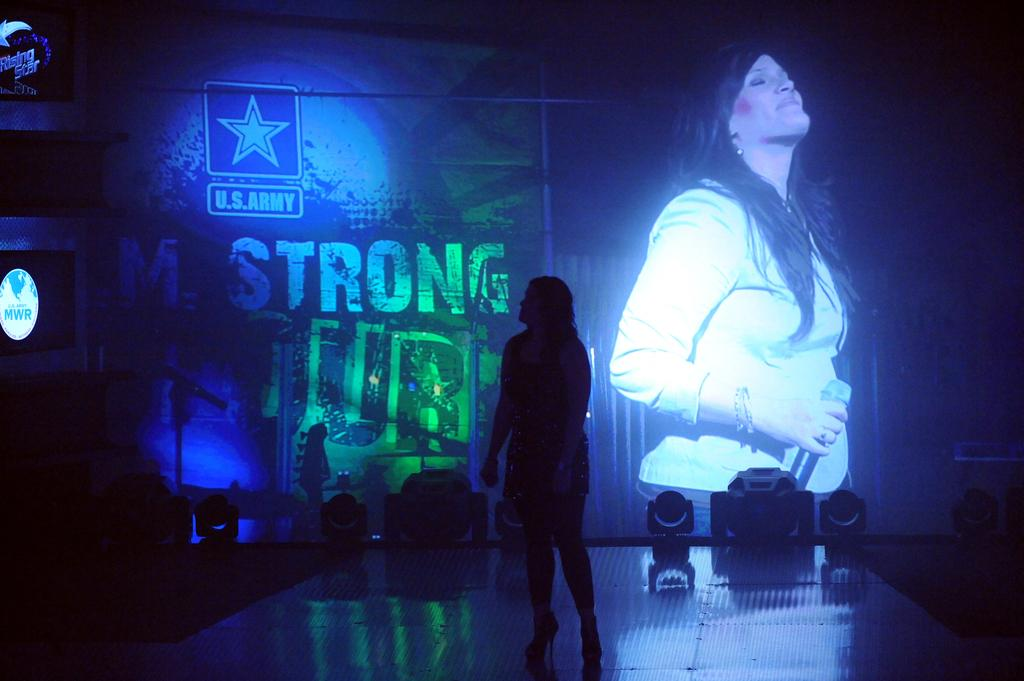What is happening on the stage in the image? There is a person on the stage in the image. What can be seen on the wall in the image? There is an image of a lady holding an object on the wall, as well as text. Can you describe the objects on the stage? Unfortunately, the facts provided do not specify the objects on the stage. What is the content of the text on the wall? The facts provided do not specify the content of the text on the wall. How many balls are being destroyed by the person on the stage? There is no mention of balls or destruction in the image. What is the person on the stage doing to the objects on the back of the stage? The facts provided do not specify the actions of the person on the stage or the presence of a back in the image. 